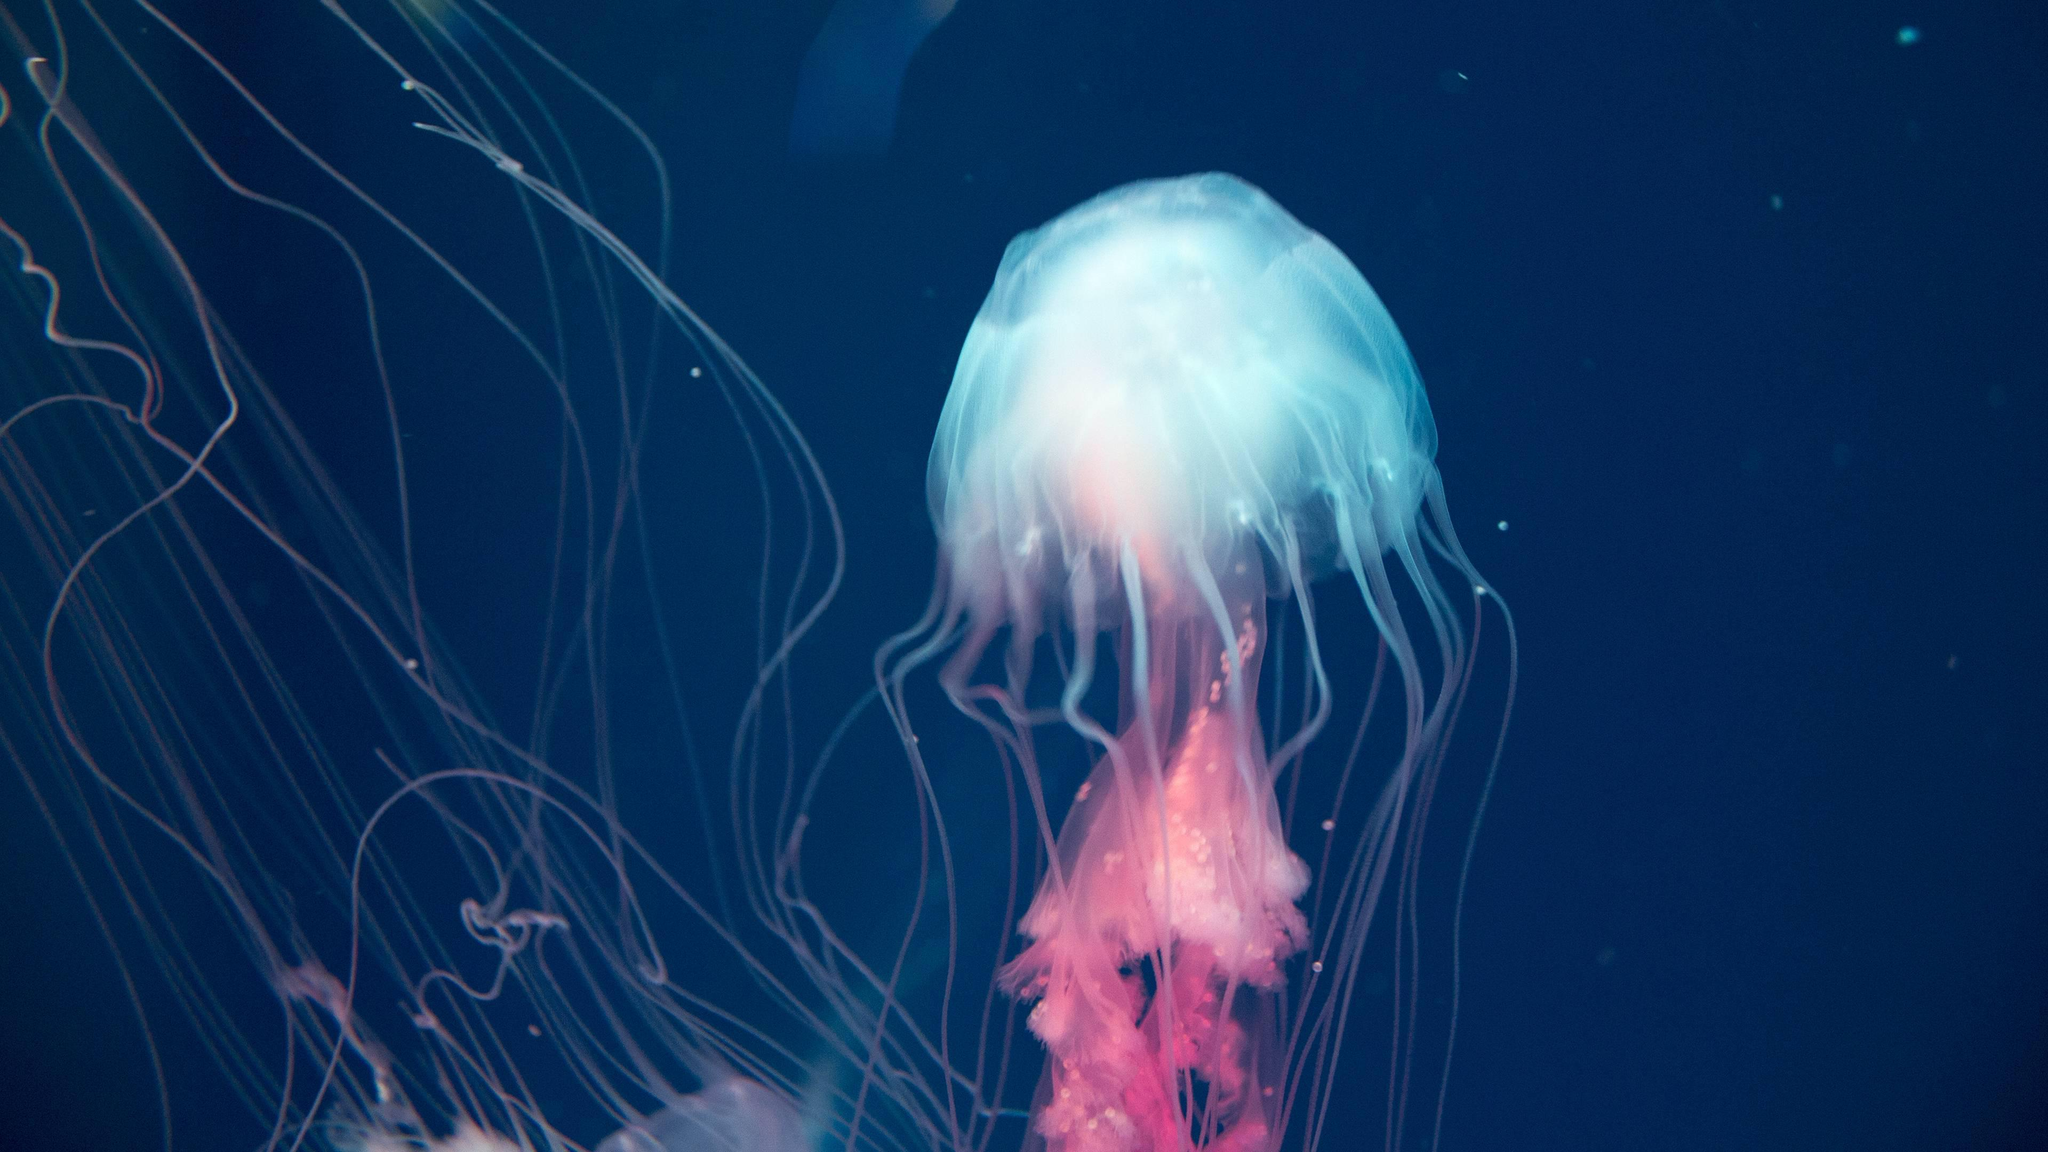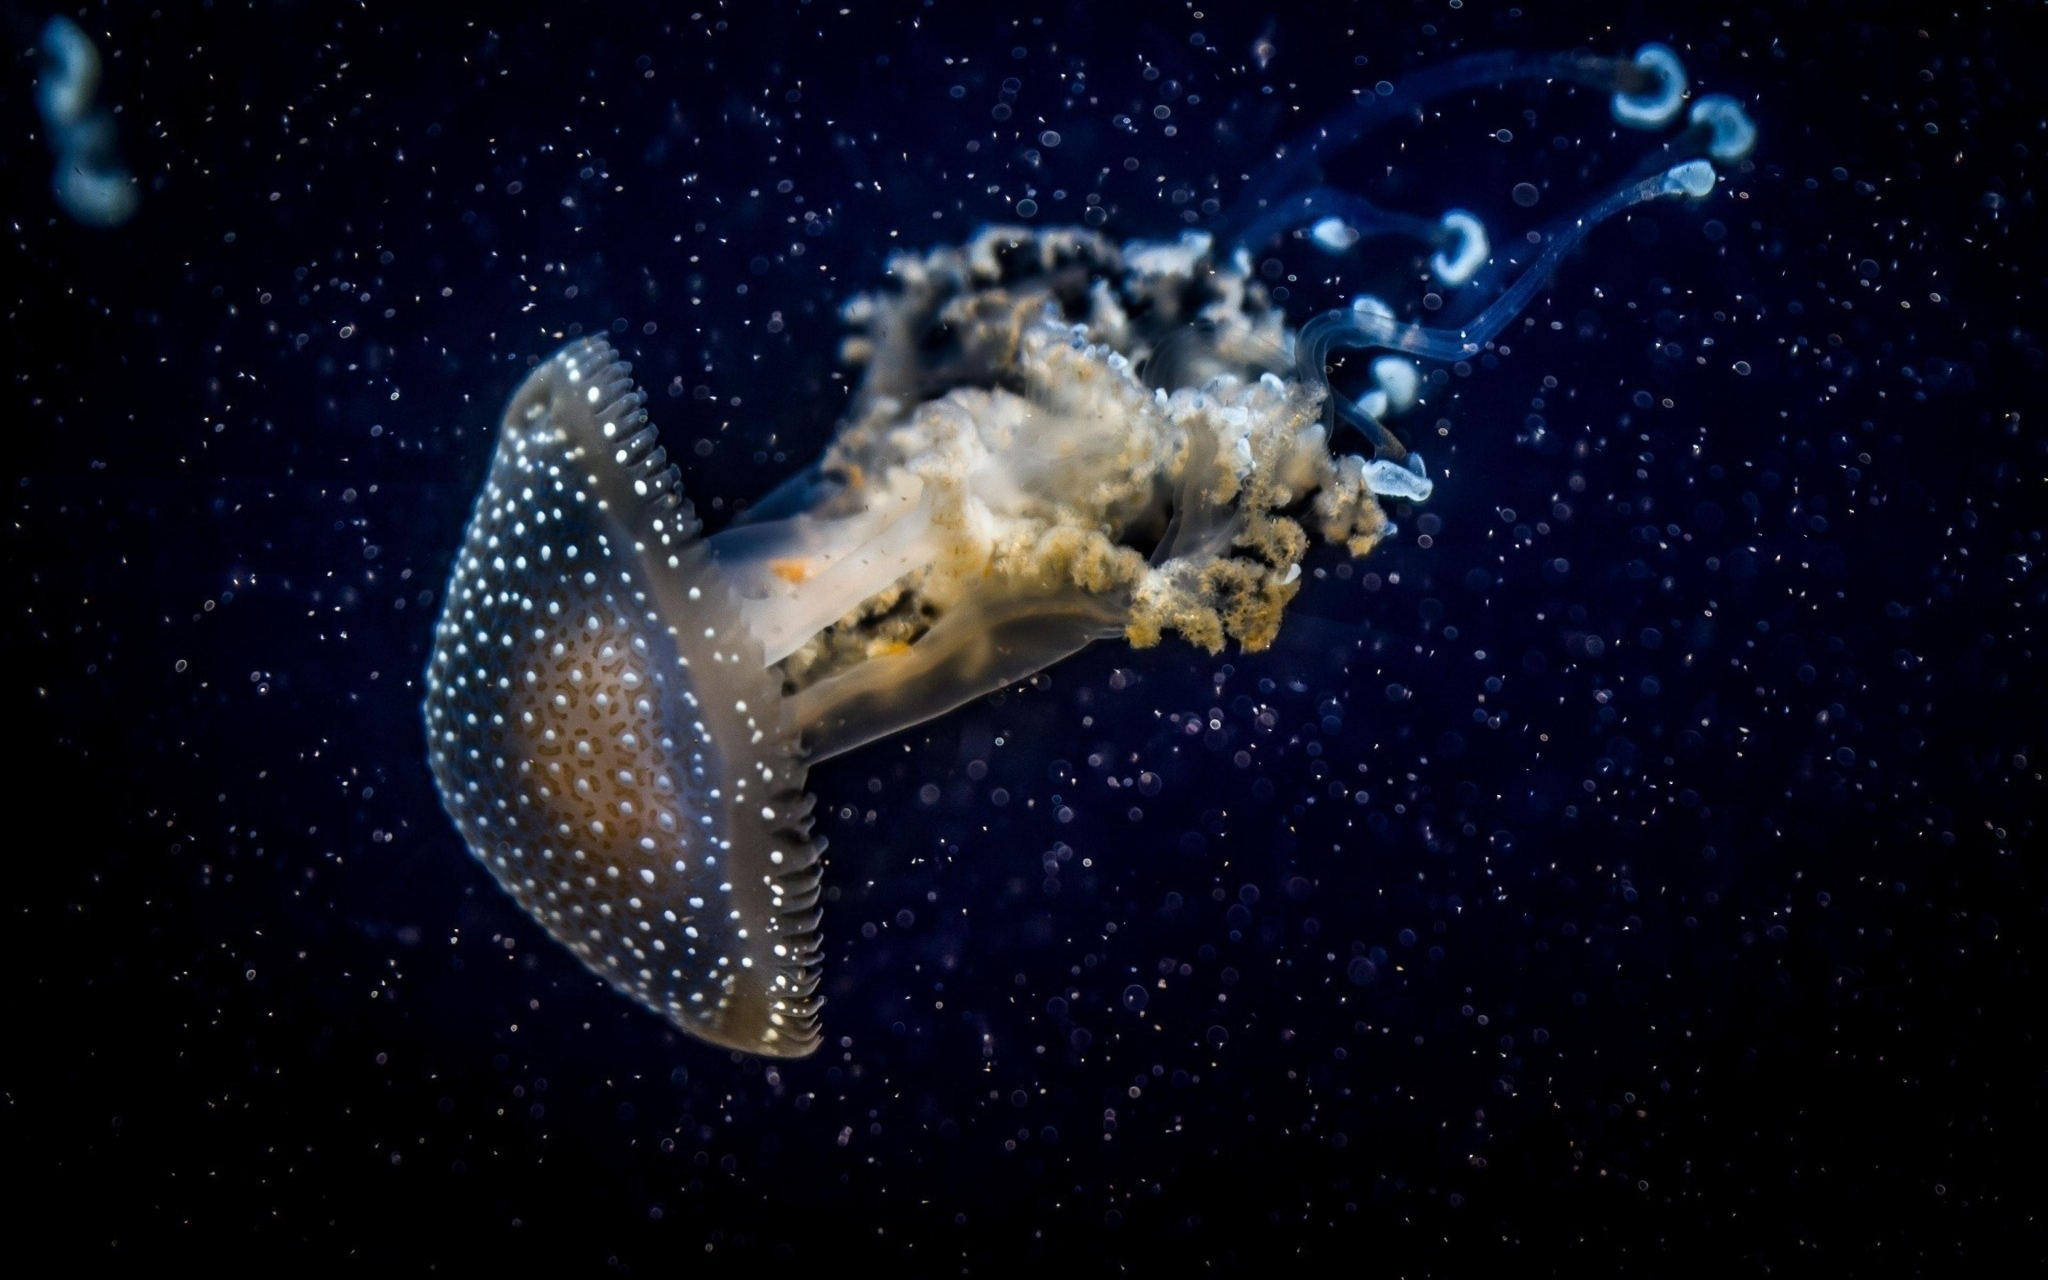The first image is the image on the left, the second image is the image on the right. Given the left and right images, does the statement "Each image contains exactly one jellyfish, and one image shows a jellyfish with its 'cap' turned rightward and its long tentacles trailing horizontally to the left." hold true? Answer yes or no. No. The first image is the image on the left, the second image is the image on the right. Considering the images on both sides, is "there is a single jellyfish swimming to the right" valid? Answer yes or no. No. 